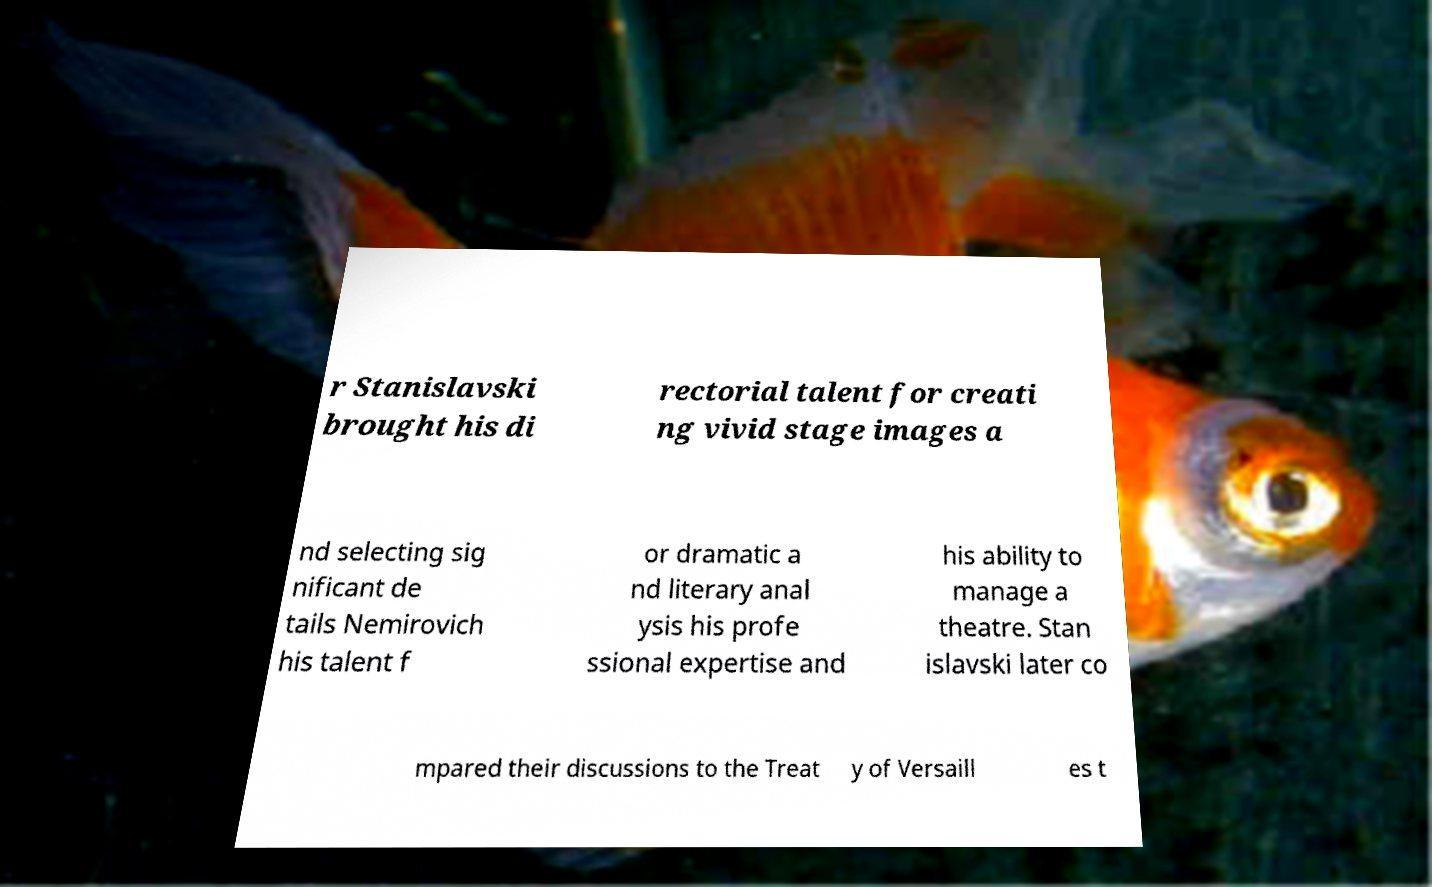Could you extract and type out the text from this image? r Stanislavski brought his di rectorial talent for creati ng vivid stage images a nd selecting sig nificant de tails Nemirovich his talent f or dramatic a nd literary anal ysis his profe ssional expertise and his ability to manage a theatre. Stan islavski later co mpared their discussions to the Treat y of Versaill es t 